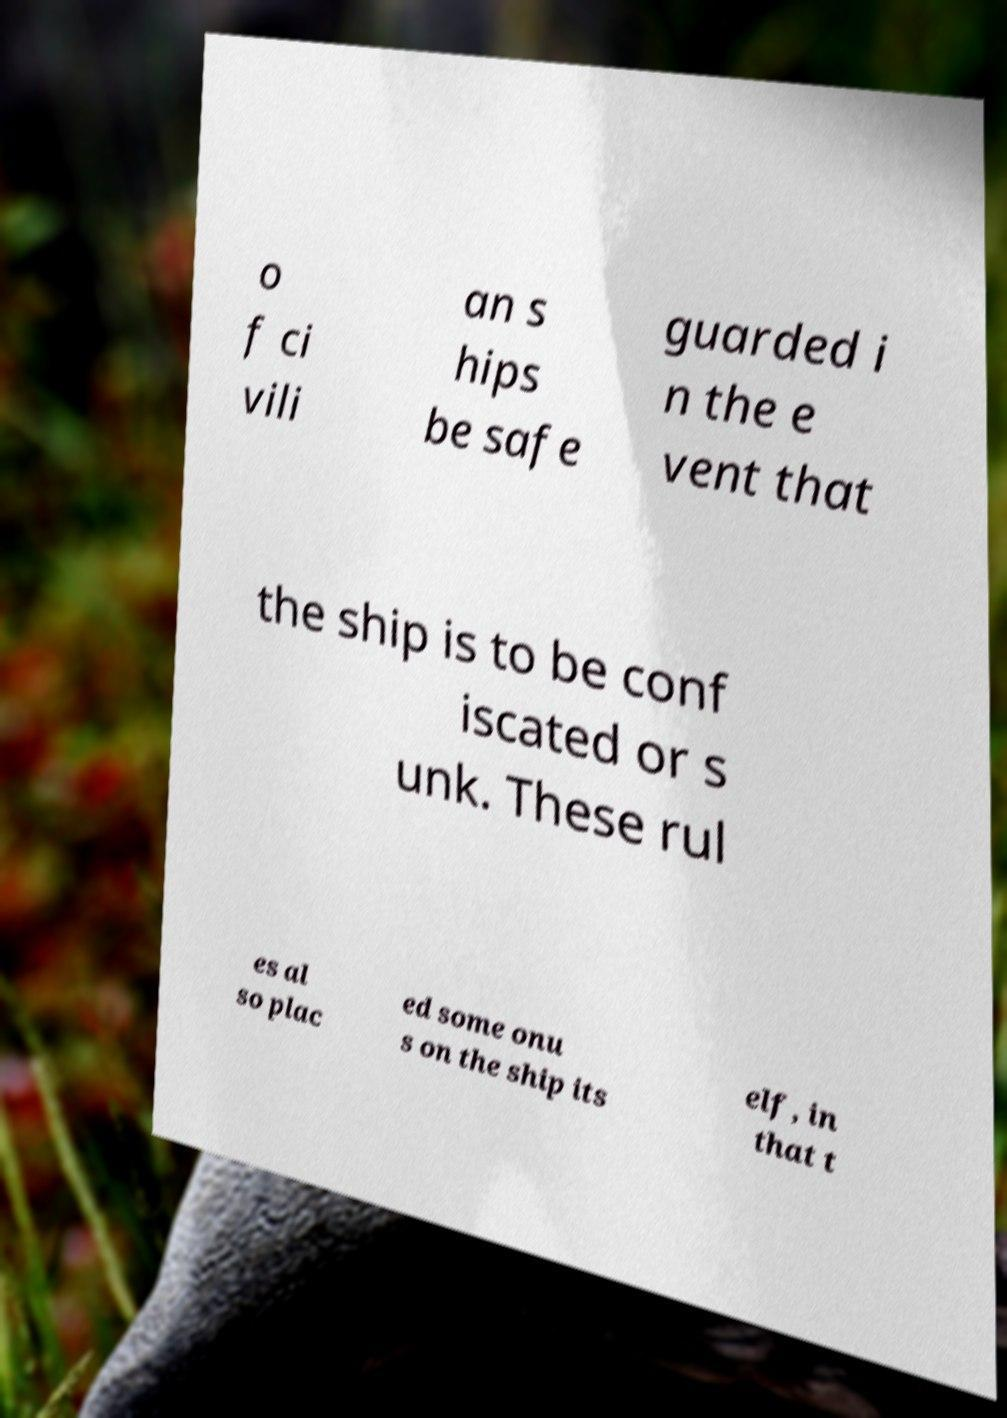Could you assist in decoding the text presented in this image and type it out clearly? o f ci vili an s hips be safe guarded i n the e vent that the ship is to be conf iscated or s unk. These rul es al so plac ed some onu s on the ship its elf, in that t 